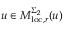<formula> <loc_0><loc_0><loc_500><loc_500>u \in M _ { l o c , r } ^ { \Sigma _ { 2 } } ( u )</formula> 